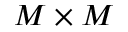<formula> <loc_0><loc_0><loc_500><loc_500>M \times M</formula> 